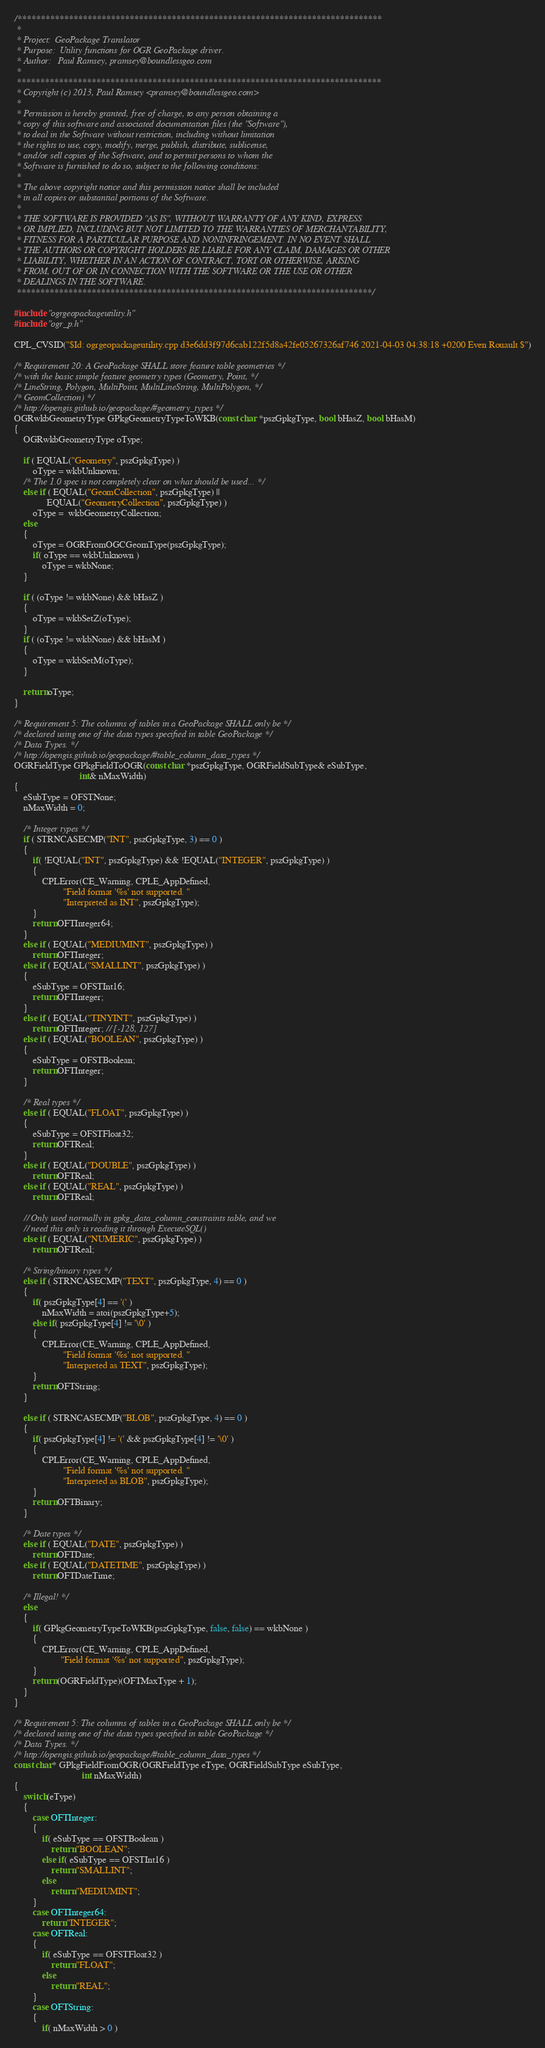Convert code to text. <code><loc_0><loc_0><loc_500><loc_500><_C++_>/******************************************************************************
 *
 * Project:  GeoPackage Translator
 * Purpose:  Utility functions for OGR GeoPackage driver.
 * Author:   Paul Ramsey, pramsey@boundlessgeo.com
 *
 ******************************************************************************
 * Copyright (c) 2013, Paul Ramsey <pramsey@boundlessgeo.com>
 *
 * Permission is hereby granted, free of charge, to any person obtaining a
 * copy of this software and associated documentation files (the "Software"),
 * to deal in the Software without restriction, including without limitation
 * the rights to use, copy, modify, merge, publish, distribute, sublicense,
 * and/or sell copies of the Software, and to permit persons to whom the
 * Software is furnished to do so, subject to the following conditions:
 *
 * The above copyright notice and this permission notice shall be included
 * in all copies or substantial portions of the Software.
 *
 * THE SOFTWARE IS PROVIDED "AS IS", WITHOUT WARRANTY OF ANY KIND, EXPRESS
 * OR IMPLIED, INCLUDING BUT NOT LIMITED TO THE WARRANTIES OF MERCHANTABILITY,
 * FITNESS FOR A PARTICULAR PURPOSE AND NONINFRINGEMENT. IN NO EVENT SHALL
 * THE AUTHORS OR COPYRIGHT HOLDERS BE LIABLE FOR ANY CLAIM, DAMAGES OR OTHER
 * LIABILITY, WHETHER IN AN ACTION OF CONTRACT, TORT OR OTHERWISE, ARISING
 * FROM, OUT OF OR IN CONNECTION WITH THE SOFTWARE OR THE USE OR OTHER
 * DEALINGS IN THE SOFTWARE.
 ****************************************************************************/

#include "ogrgeopackageutility.h"
#include "ogr_p.h"

CPL_CVSID("$Id: ogrgeopackageutility.cpp d3e6dd3f97d6cab122f5d8a42fe05267326af746 2021-04-03 04:38:18 +0200 Even Rouault $")

/* Requirement 20: A GeoPackage SHALL store feature table geometries */
/* with the basic simple feature geometry types (Geometry, Point, */
/* LineString, Polygon, MultiPoint, MultiLineString, MultiPolygon, */
/* GeomCollection) */
/* http://opengis.github.io/geopackage/#geometry_types */
OGRwkbGeometryType GPkgGeometryTypeToWKB(const char *pszGpkgType, bool bHasZ, bool bHasM)
{
    OGRwkbGeometryType oType;

    if ( EQUAL("Geometry", pszGpkgType) )
        oType = wkbUnknown;
    /* The 1.0 spec is not completely clear on what should be used... */
    else if ( EQUAL("GeomCollection", pszGpkgType) ||
              EQUAL("GeometryCollection", pszGpkgType) )
        oType =  wkbGeometryCollection;
    else
    {
        oType = OGRFromOGCGeomType(pszGpkgType);
        if( oType == wkbUnknown )
            oType = wkbNone;
    }

    if ( (oType != wkbNone) && bHasZ )
    {
        oType = wkbSetZ(oType);
    }
    if ( (oType != wkbNone) && bHasM )
    {
        oType = wkbSetM(oType);
    }

    return oType;
}

/* Requirement 5: The columns of tables in a GeoPackage SHALL only be */
/* declared using one of the data types specified in table GeoPackage */
/* Data Types. */
/* http://opengis.github.io/geopackage/#table_column_data_types */
OGRFieldType GPkgFieldToOGR(const char *pszGpkgType, OGRFieldSubType& eSubType,
                            int& nMaxWidth)
{
    eSubType = OFSTNone;
    nMaxWidth = 0;

    /* Integer types */
    if ( STRNCASECMP("INT", pszGpkgType, 3) == 0 )
    {
        if( !EQUAL("INT", pszGpkgType) && !EQUAL("INTEGER", pszGpkgType) )
        {
            CPLError(CE_Warning, CPLE_AppDefined,
                     "Field format '%s' not supported. "
                     "Interpreted as INT", pszGpkgType);
        }
        return OFTInteger64;
    }
    else if ( EQUAL("MEDIUMINT", pszGpkgType) )
        return OFTInteger;
    else if ( EQUAL("SMALLINT", pszGpkgType) )
    {
        eSubType = OFSTInt16;
        return OFTInteger;
    }
    else if ( EQUAL("TINYINT", pszGpkgType) )
        return OFTInteger; // [-128, 127]
    else if ( EQUAL("BOOLEAN", pszGpkgType) )
    {
        eSubType = OFSTBoolean;
        return OFTInteger;
    }

    /* Real types */
    else if ( EQUAL("FLOAT", pszGpkgType) )
    {
        eSubType = OFSTFloat32;
        return OFTReal;
    }
    else if ( EQUAL("DOUBLE", pszGpkgType) )
        return OFTReal;
    else if ( EQUAL("REAL", pszGpkgType) )
        return OFTReal;

    // Only used normally in gpkg_data_column_constraints table, and we
    // need this only is reading it through ExecuteSQL()
    else if ( EQUAL("NUMERIC", pszGpkgType) )
        return OFTReal;

    /* String/binary types */
    else if ( STRNCASECMP("TEXT", pszGpkgType, 4) == 0 )
    {
        if( pszGpkgType[4] == '(' )
            nMaxWidth = atoi(pszGpkgType+5);
        else if( pszGpkgType[4] != '\0' )
        {
            CPLError(CE_Warning, CPLE_AppDefined,
                     "Field format '%s' not supported. "
                     "Interpreted as TEXT", pszGpkgType);
        }
        return OFTString;
    }

    else if ( STRNCASECMP("BLOB", pszGpkgType, 4) == 0 )
    {
        if( pszGpkgType[4] != '(' && pszGpkgType[4] != '\0' )
        {
            CPLError(CE_Warning, CPLE_AppDefined,
                     "Field format '%s' not supported. "
                     "Interpreted as BLOB", pszGpkgType);
        }
        return OFTBinary;
    }

    /* Date types */
    else if ( EQUAL("DATE", pszGpkgType) )
        return OFTDate;
    else if ( EQUAL("DATETIME", pszGpkgType) )
        return OFTDateTime;

    /* Illegal! */
    else
    {
        if( GPkgGeometryTypeToWKB(pszGpkgType, false, false) == wkbNone )
        {
            CPLError(CE_Warning, CPLE_AppDefined,
                    "Field format '%s' not supported", pszGpkgType);
        }
        return (OGRFieldType)(OFTMaxType + 1);
    }
}

/* Requirement 5: The columns of tables in a GeoPackage SHALL only be */
/* declared using one of the data types specified in table GeoPackage */
/* Data Types. */
/* http://opengis.github.io/geopackage/#table_column_data_types */
const char* GPkgFieldFromOGR(OGRFieldType eType, OGRFieldSubType eSubType,
                             int nMaxWidth)
{
    switch(eType)
    {
        case OFTInteger:
        {
            if( eSubType == OFSTBoolean )
                return "BOOLEAN";
            else if( eSubType == OFSTInt16 )
                return "SMALLINT";
            else
                return "MEDIUMINT";
        }
        case OFTInteger64:
            return "INTEGER";
        case OFTReal:
        {
            if( eSubType == OFSTFloat32 )
                return "FLOAT";
            else
                return "REAL";
        }
        case OFTString:
        {
            if( nMaxWidth > 0 )</code> 